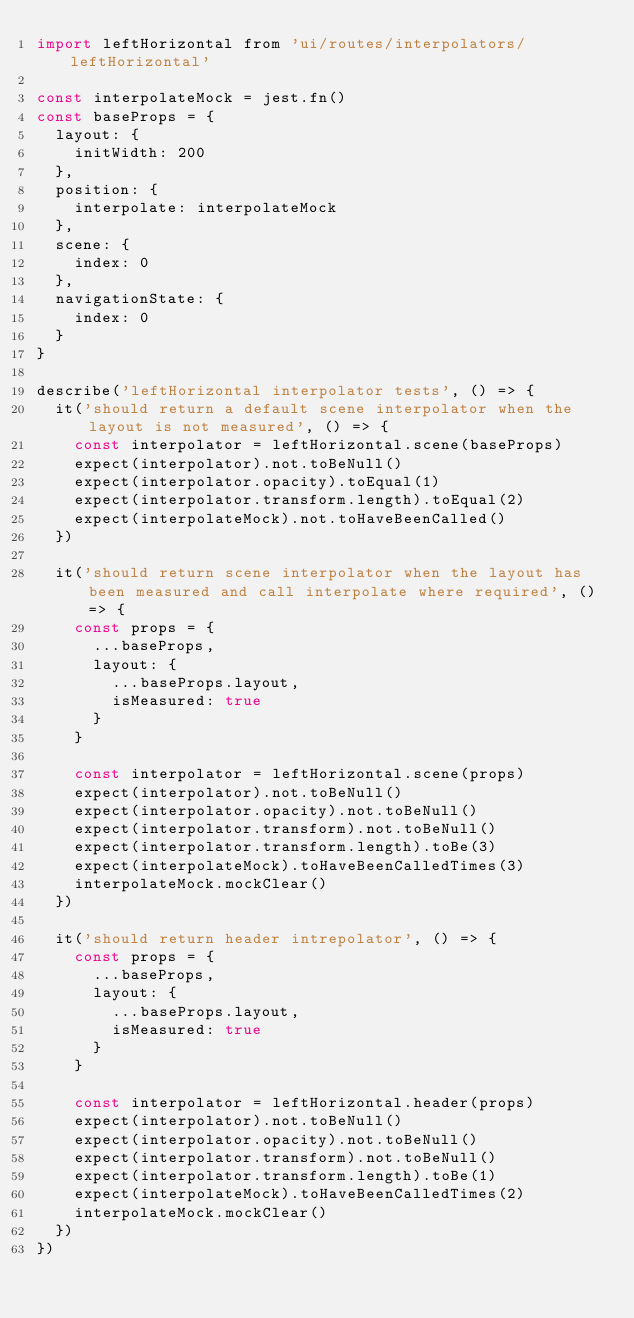Convert code to text. <code><loc_0><loc_0><loc_500><loc_500><_JavaScript_>import leftHorizontal from 'ui/routes/interpolators/leftHorizontal'

const interpolateMock = jest.fn()
const baseProps = {
  layout: {
    initWidth: 200
  },
  position: {
    interpolate: interpolateMock
  },
  scene: {
    index: 0
  },
  navigationState: {
    index: 0
  }
}

describe('leftHorizontal interpolator tests', () => {
  it('should return a default scene interpolator when the layout is not measured', () => {
    const interpolator = leftHorizontal.scene(baseProps)
    expect(interpolator).not.toBeNull()
    expect(interpolator.opacity).toEqual(1)
    expect(interpolator.transform.length).toEqual(2)
    expect(interpolateMock).not.toHaveBeenCalled()
  })

  it('should return scene interpolator when the layout has been measured and call interpolate where required', () => {
    const props = {
      ...baseProps,
      layout: {
        ...baseProps.layout,
        isMeasured: true
      }
    }

    const interpolator = leftHorizontal.scene(props)
    expect(interpolator).not.toBeNull()
    expect(interpolator.opacity).not.toBeNull()
    expect(interpolator.transform).not.toBeNull()
    expect(interpolator.transform.length).toBe(3)
    expect(interpolateMock).toHaveBeenCalledTimes(3)
    interpolateMock.mockClear()
  })

  it('should return header intrepolator', () => {
    const props = {
      ...baseProps,
      layout: {
        ...baseProps.layout,
        isMeasured: true
      }
    }

    const interpolator = leftHorizontal.header(props)
    expect(interpolator).not.toBeNull()
    expect(interpolator.opacity).not.toBeNull()
    expect(interpolator.transform).not.toBeNull()
    expect(interpolator.transform.length).toBe(1)
    expect(interpolateMock).toHaveBeenCalledTimes(2)
    interpolateMock.mockClear()
  })
})
</code> 